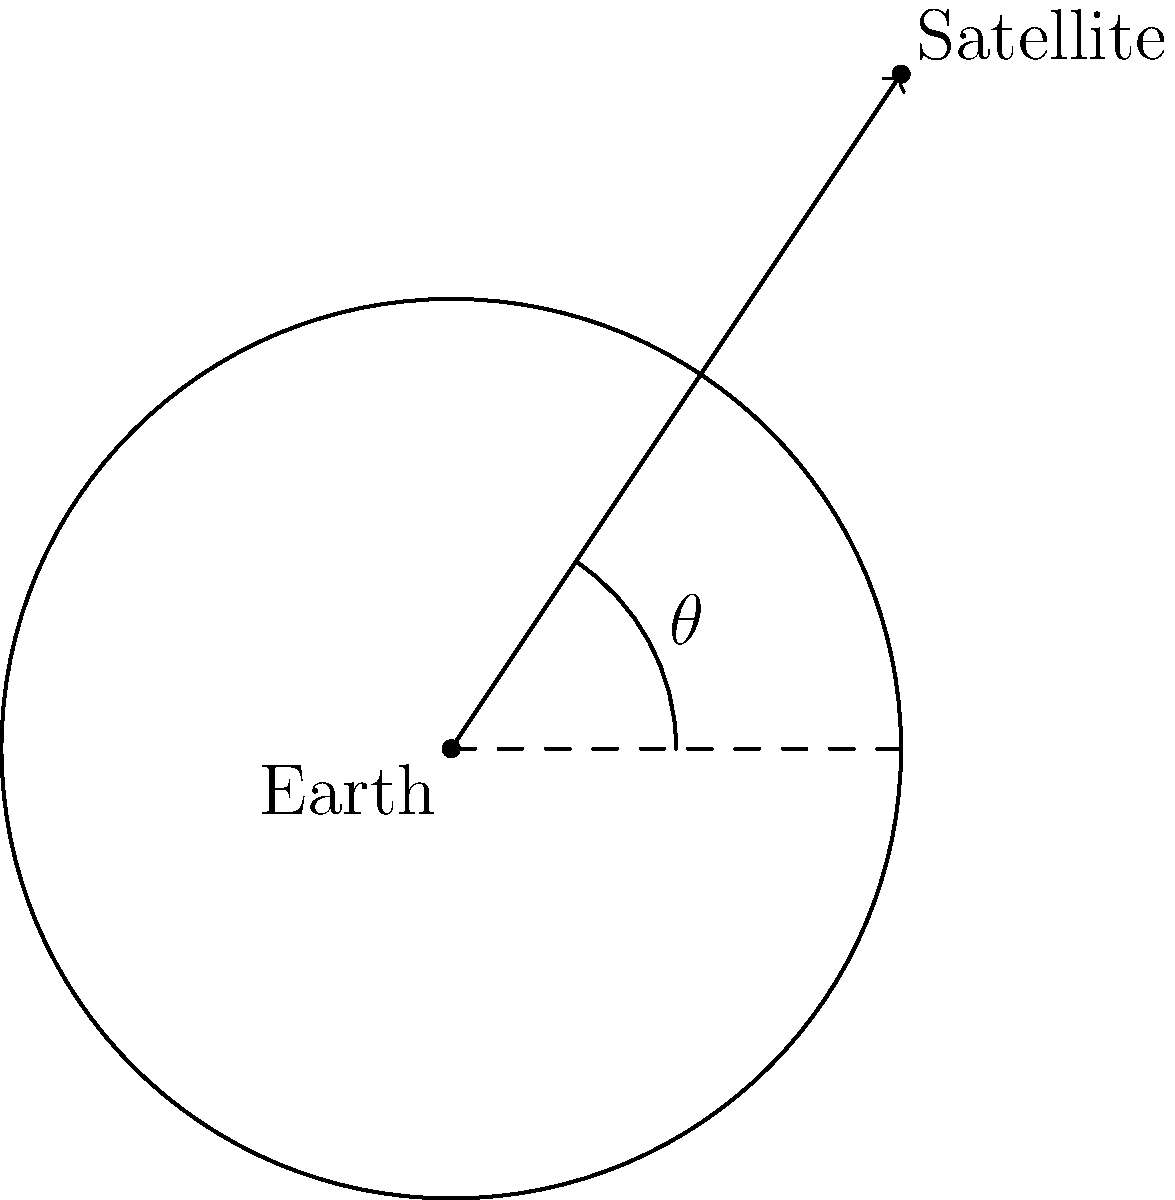Consider a satellite orbiting Earth as shown in the diagram. The optimal angle of inclination ($\theta$) for a satellite's orbit depends on its intended purpose and altitude. For a typical communication satellite in geostationary orbit, what is the approximate angle of inclination with respect to Earth's equatorial plane? To determine the optimal angle of inclination for a geostationary communication satellite, we need to consider the following factors:

1. Geostationary orbit: This is a circular orbit above Earth's equator with a period equal to Earth's rotational period.

2. Altitude: Geostationary satellites orbit at an altitude of approximately 35,786 km above Earth's surface.

3. Purpose: Communication satellites need to maintain a fixed position relative to Earth's surface to provide continuous coverage to specific regions.

4. Earth's equatorial plane: This is the reference plane for measuring the inclination angle.

Given these considerations:

1. A geostationary orbit requires the satellite to remain above a fixed point on Earth's equator.

2. To achieve this, the satellite must orbit in the same plane as Earth's equator.

3. The angle of inclination is measured between the satellite's orbital plane and Earth's equatorial plane.

4. For a geostationary orbit, the orbital plane must coincide with the equatorial plane.

Therefore, the optimal angle of inclination for a geostationary communication satellite is 0°. This allows the satellite to maintain its position relative to Earth's surface, providing consistent coverage to its target area.
Answer: 0° 